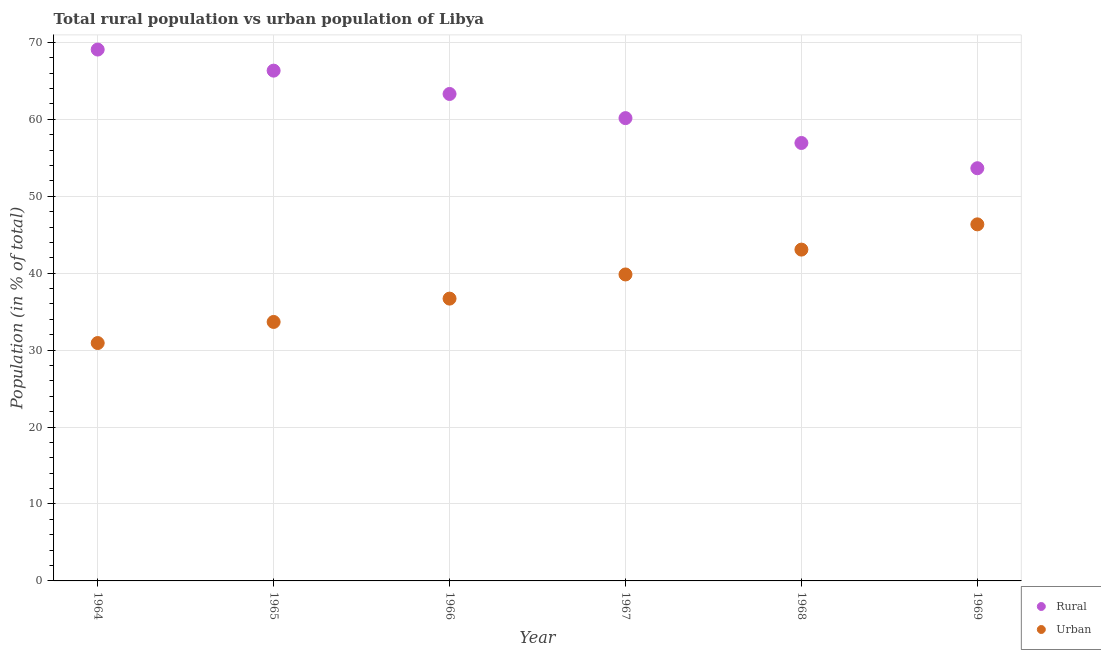What is the rural population in 1967?
Provide a succinct answer. 60.16. Across all years, what is the maximum rural population?
Give a very brief answer. 69.08. Across all years, what is the minimum urban population?
Ensure brevity in your answer.  30.92. In which year was the urban population maximum?
Ensure brevity in your answer.  1969. In which year was the rural population minimum?
Offer a very short reply. 1969. What is the total urban population in the graph?
Keep it short and to the point. 230.55. What is the difference between the urban population in 1964 and that in 1967?
Offer a very short reply. -8.91. What is the difference between the rural population in 1966 and the urban population in 1964?
Offer a terse response. 32.38. What is the average urban population per year?
Offer a very short reply. 38.42. In the year 1969, what is the difference between the urban population and rural population?
Offer a terse response. -7.3. In how many years, is the urban population greater than 54 %?
Provide a short and direct response. 0. What is the ratio of the rural population in 1966 to that in 1968?
Give a very brief answer. 1.11. Is the urban population in 1966 less than that in 1967?
Give a very brief answer. Yes. What is the difference between the highest and the second highest urban population?
Keep it short and to the point. 3.28. What is the difference between the highest and the lowest urban population?
Ensure brevity in your answer.  15.43. In how many years, is the urban population greater than the average urban population taken over all years?
Make the answer very short. 3. Is the sum of the urban population in 1965 and 1969 greater than the maximum rural population across all years?
Your answer should be compact. Yes. Does the rural population monotonically increase over the years?
Your answer should be very brief. No. Is the urban population strictly greater than the rural population over the years?
Your answer should be very brief. No. Is the rural population strictly less than the urban population over the years?
Provide a succinct answer. No. How many dotlines are there?
Make the answer very short. 2. What is the difference between two consecutive major ticks on the Y-axis?
Keep it short and to the point. 10. Are the values on the major ticks of Y-axis written in scientific E-notation?
Offer a terse response. No. What is the title of the graph?
Make the answer very short. Total rural population vs urban population of Libya. Does "Under-5(male)" appear as one of the legend labels in the graph?
Offer a very short reply. No. What is the label or title of the Y-axis?
Your answer should be compact. Population (in % of total). What is the Population (in % of total) in Rural in 1964?
Your answer should be compact. 69.08. What is the Population (in % of total) in Urban in 1964?
Give a very brief answer. 30.92. What is the Population (in % of total) of Rural in 1965?
Offer a terse response. 66.33. What is the Population (in % of total) of Urban in 1965?
Give a very brief answer. 33.67. What is the Population (in % of total) of Rural in 1966?
Keep it short and to the point. 63.3. What is the Population (in % of total) in Urban in 1966?
Keep it short and to the point. 36.7. What is the Population (in % of total) of Rural in 1967?
Your answer should be very brief. 60.16. What is the Population (in % of total) in Urban in 1967?
Keep it short and to the point. 39.84. What is the Population (in % of total) of Rural in 1968?
Your answer should be compact. 56.93. What is the Population (in % of total) in Urban in 1968?
Keep it short and to the point. 43.07. What is the Population (in % of total) in Rural in 1969?
Your response must be concise. 53.65. What is the Population (in % of total) in Urban in 1969?
Your answer should be very brief. 46.35. Across all years, what is the maximum Population (in % of total) of Rural?
Provide a short and direct response. 69.08. Across all years, what is the maximum Population (in % of total) in Urban?
Your answer should be very brief. 46.35. Across all years, what is the minimum Population (in % of total) of Rural?
Your response must be concise. 53.65. Across all years, what is the minimum Population (in % of total) of Urban?
Offer a very short reply. 30.92. What is the total Population (in % of total) in Rural in the graph?
Your response must be concise. 369.45. What is the total Population (in % of total) of Urban in the graph?
Make the answer very short. 230.55. What is the difference between the Population (in % of total) in Rural in 1964 and that in 1965?
Ensure brevity in your answer.  2.74. What is the difference between the Population (in % of total) in Urban in 1964 and that in 1965?
Keep it short and to the point. -2.74. What is the difference between the Population (in % of total) in Rural in 1964 and that in 1966?
Your response must be concise. 5.77. What is the difference between the Population (in % of total) of Urban in 1964 and that in 1966?
Your answer should be very brief. -5.77. What is the difference between the Population (in % of total) of Rural in 1964 and that in 1967?
Offer a terse response. 8.91. What is the difference between the Population (in % of total) in Urban in 1964 and that in 1967?
Ensure brevity in your answer.  -8.91. What is the difference between the Population (in % of total) of Rural in 1964 and that in 1968?
Offer a very short reply. 12.15. What is the difference between the Population (in % of total) of Urban in 1964 and that in 1968?
Keep it short and to the point. -12.15. What is the difference between the Population (in % of total) of Rural in 1964 and that in 1969?
Offer a very short reply. 15.43. What is the difference between the Population (in % of total) in Urban in 1964 and that in 1969?
Your answer should be compact. -15.43. What is the difference between the Population (in % of total) of Rural in 1965 and that in 1966?
Provide a succinct answer. 3.03. What is the difference between the Population (in % of total) in Urban in 1965 and that in 1966?
Your answer should be very brief. -3.03. What is the difference between the Population (in % of total) of Rural in 1965 and that in 1967?
Offer a terse response. 6.17. What is the difference between the Population (in % of total) in Urban in 1965 and that in 1967?
Offer a terse response. -6.17. What is the difference between the Population (in % of total) in Rural in 1965 and that in 1968?
Your response must be concise. 9.4. What is the difference between the Population (in % of total) in Urban in 1965 and that in 1968?
Your answer should be compact. -9.4. What is the difference between the Population (in % of total) in Rural in 1965 and that in 1969?
Provide a succinct answer. 12.69. What is the difference between the Population (in % of total) in Urban in 1965 and that in 1969?
Your answer should be very brief. -12.69. What is the difference between the Population (in % of total) of Rural in 1966 and that in 1967?
Make the answer very short. 3.14. What is the difference between the Population (in % of total) in Urban in 1966 and that in 1967?
Make the answer very short. -3.14. What is the difference between the Population (in % of total) of Rural in 1966 and that in 1968?
Keep it short and to the point. 6.37. What is the difference between the Population (in % of total) of Urban in 1966 and that in 1968?
Your response must be concise. -6.37. What is the difference between the Population (in % of total) of Rural in 1966 and that in 1969?
Provide a succinct answer. 9.65. What is the difference between the Population (in % of total) of Urban in 1966 and that in 1969?
Keep it short and to the point. -9.65. What is the difference between the Population (in % of total) in Rural in 1967 and that in 1968?
Ensure brevity in your answer.  3.23. What is the difference between the Population (in % of total) of Urban in 1967 and that in 1968?
Provide a succinct answer. -3.23. What is the difference between the Population (in % of total) in Rural in 1967 and that in 1969?
Provide a short and direct response. 6.51. What is the difference between the Population (in % of total) in Urban in 1967 and that in 1969?
Keep it short and to the point. -6.51. What is the difference between the Population (in % of total) in Rural in 1968 and that in 1969?
Keep it short and to the point. 3.28. What is the difference between the Population (in % of total) in Urban in 1968 and that in 1969?
Provide a short and direct response. -3.28. What is the difference between the Population (in % of total) of Rural in 1964 and the Population (in % of total) of Urban in 1965?
Keep it short and to the point. 35.41. What is the difference between the Population (in % of total) of Rural in 1964 and the Population (in % of total) of Urban in 1966?
Your answer should be very brief. 32.38. What is the difference between the Population (in % of total) of Rural in 1964 and the Population (in % of total) of Urban in 1967?
Offer a terse response. 29.24. What is the difference between the Population (in % of total) in Rural in 1964 and the Population (in % of total) in Urban in 1968?
Offer a terse response. 26.01. What is the difference between the Population (in % of total) of Rural in 1964 and the Population (in % of total) of Urban in 1969?
Your answer should be compact. 22.72. What is the difference between the Population (in % of total) in Rural in 1965 and the Population (in % of total) in Urban in 1966?
Make the answer very short. 29.64. What is the difference between the Population (in % of total) of Rural in 1965 and the Population (in % of total) of Urban in 1967?
Offer a very short reply. 26.5. What is the difference between the Population (in % of total) in Rural in 1965 and the Population (in % of total) in Urban in 1968?
Ensure brevity in your answer.  23.26. What is the difference between the Population (in % of total) in Rural in 1965 and the Population (in % of total) in Urban in 1969?
Offer a very short reply. 19.98. What is the difference between the Population (in % of total) of Rural in 1966 and the Population (in % of total) of Urban in 1967?
Provide a succinct answer. 23.46. What is the difference between the Population (in % of total) in Rural in 1966 and the Population (in % of total) in Urban in 1968?
Offer a terse response. 20.23. What is the difference between the Population (in % of total) of Rural in 1966 and the Population (in % of total) of Urban in 1969?
Keep it short and to the point. 16.95. What is the difference between the Population (in % of total) in Rural in 1967 and the Population (in % of total) in Urban in 1968?
Offer a terse response. 17.09. What is the difference between the Population (in % of total) in Rural in 1967 and the Population (in % of total) in Urban in 1969?
Provide a short and direct response. 13.81. What is the difference between the Population (in % of total) of Rural in 1968 and the Population (in % of total) of Urban in 1969?
Your response must be concise. 10.58. What is the average Population (in % of total) of Rural per year?
Give a very brief answer. 61.58. What is the average Population (in % of total) in Urban per year?
Offer a very short reply. 38.42. In the year 1964, what is the difference between the Population (in % of total) in Rural and Population (in % of total) in Urban?
Provide a succinct answer. 38.15. In the year 1965, what is the difference between the Population (in % of total) of Rural and Population (in % of total) of Urban?
Give a very brief answer. 32.67. In the year 1966, what is the difference between the Population (in % of total) of Rural and Population (in % of total) of Urban?
Your answer should be very brief. 26.6. In the year 1967, what is the difference between the Population (in % of total) in Rural and Population (in % of total) in Urban?
Give a very brief answer. 20.32. In the year 1968, what is the difference between the Population (in % of total) in Rural and Population (in % of total) in Urban?
Offer a very short reply. 13.86. In the year 1969, what is the difference between the Population (in % of total) in Rural and Population (in % of total) in Urban?
Your response must be concise. 7.3. What is the ratio of the Population (in % of total) in Rural in 1964 to that in 1965?
Provide a succinct answer. 1.04. What is the ratio of the Population (in % of total) in Urban in 1964 to that in 1965?
Ensure brevity in your answer.  0.92. What is the ratio of the Population (in % of total) in Rural in 1964 to that in 1966?
Provide a succinct answer. 1.09. What is the ratio of the Population (in % of total) in Urban in 1964 to that in 1966?
Keep it short and to the point. 0.84. What is the ratio of the Population (in % of total) of Rural in 1964 to that in 1967?
Offer a terse response. 1.15. What is the ratio of the Population (in % of total) in Urban in 1964 to that in 1967?
Make the answer very short. 0.78. What is the ratio of the Population (in % of total) in Rural in 1964 to that in 1968?
Offer a terse response. 1.21. What is the ratio of the Population (in % of total) of Urban in 1964 to that in 1968?
Your answer should be very brief. 0.72. What is the ratio of the Population (in % of total) in Rural in 1964 to that in 1969?
Make the answer very short. 1.29. What is the ratio of the Population (in % of total) in Urban in 1964 to that in 1969?
Your response must be concise. 0.67. What is the ratio of the Population (in % of total) of Rural in 1965 to that in 1966?
Offer a terse response. 1.05. What is the ratio of the Population (in % of total) in Urban in 1965 to that in 1966?
Give a very brief answer. 0.92. What is the ratio of the Population (in % of total) in Rural in 1965 to that in 1967?
Provide a short and direct response. 1.1. What is the ratio of the Population (in % of total) in Urban in 1965 to that in 1967?
Offer a very short reply. 0.85. What is the ratio of the Population (in % of total) of Rural in 1965 to that in 1968?
Give a very brief answer. 1.17. What is the ratio of the Population (in % of total) of Urban in 1965 to that in 1968?
Offer a terse response. 0.78. What is the ratio of the Population (in % of total) in Rural in 1965 to that in 1969?
Offer a terse response. 1.24. What is the ratio of the Population (in % of total) in Urban in 1965 to that in 1969?
Offer a very short reply. 0.73. What is the ratio of the Population (in % of total) of Rural in 1966 to that in 1967?
Offer a very short reply. 1.05. What is the ratio of the Population (in % of total) in Urban in 1966 to that in 1967?
Give a very brief answer. 0.92. What is the ratio of the Population (in % of total) of Rural in 1966 to that in 1968?
Keep it short and to the point. 1.11. What is the ratio of the Population (in % of total) in Urban in 1966 to that in 1968?
Make the answer very short. 0.85. What is the ratio of the Population (in % of total) of Rural in 1966 to that in 1969?
Your answer should be very brief. 1.18. What is the ratio of the Population (in % of total) of Urban in 1966 to that in 1969?
Make the answer very short. 0.79. What is the ratio of the Population (in % of total) of Rural in 1967 to that in 1968?
Ensure brevity in your answer.  1.06. What is the ratio of the Population (in % of total) in Urban in 1967 to that in 1968?
Your response must be concise. 0.93. What is the ratio of the Population (in % of total) in Rural in 1967 to that in 1969?
Ensure brevity in your answer.  1.12. What is the ratio of the Population (in % of total) in Urban in 1967 to that in 1969?
Provide a short and direct response. 0.86. What is the ratio of the Population (in % of total) of Rural in 1968 to that in 1969?
Offer a very short reply. 1.06. What is the ratio of the Population (in % of total) of Urban in 1968 to that in 1969?
Keep it short and to the point. 0.93. What is the difference between the highest and the second highest Population (in % of total) of Rural?
Offer a terse response. 2.74. What is the difference between the highest and the second highest Population (in % of total) in Urban?
Give a very brief answer. 3.28. What is the difference between the highest and the lowest Population (in % of total) of Rural?
Ensure brevity in your answer.  15.43. What is the difference between the highest and the lowest Population (in % of total) in Urban?
Offer a very short reply. 15.43. 